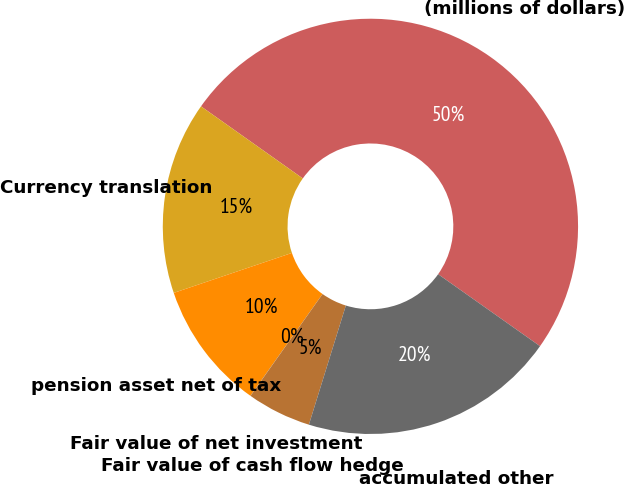Convert chart to OTSL. <chart><loc_0><loc_0><loc_500><loc_500><pie_chart><fcel>(millions of dollars)<fcel>Currency translation<fcel>pension asset net of tax<fcel>Fair value of net investment<fcel>Fair value of cash flow hedge<fcel>accumulated other<nl><fcel>49.98%<fcel>15.0%<fcel>10.0%<fcel>0.01%<fcel>5.01%<fcel>20.0%<nl></chart> 